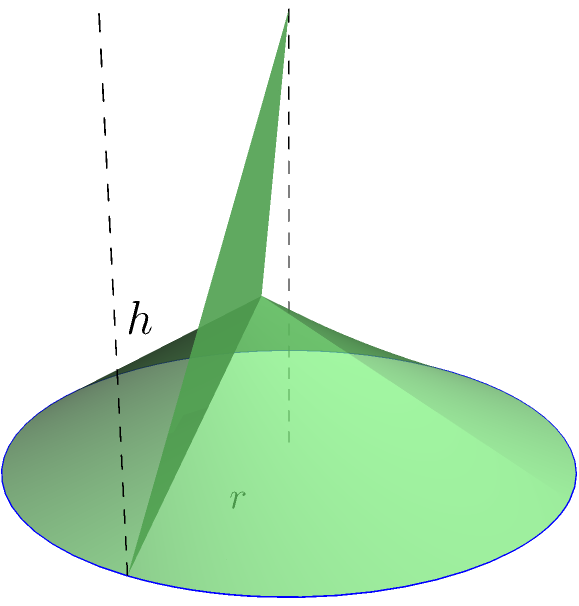During the Kalimudan Festival in Sultan Kudarat, traditional cone-shaped hats are worn. If a hat has a base radius of 20 cm and a height of 30 cm, what is its volume in cubic centimeters? Round your answer to the nearest whole number. To solve this problem, we'll use the formula for the volume of a cone:

$$V = \frac{1}{3}\pi r^2 h$$

Where:
$V$ = volume
$r$ = radius of the base
$h$ = height of the cone

Given:
$r = 20$ cm
$h = 30$ cm

Let's substitute these values into the formula:

$$V = \frac{1}{3}\pi (20\text{ cm})^2 (30\text{ cm})$$

$$V = \frac{1}{3}\pi (400\text{ cm}^2) (30\text{ cm})$$

$$V = \frac{1}{3}\pi (12000\text{ cm}^3)$$

$$V = 4000\pi\text{ cm}^3$$

Now, let's calculate this value:

$$V \approx 12566.37\text{ cm}^3$$

Rounding to the nearest whole number:

$$V \approx 12566\text{ cm}^3$$
Answer: 12566 cm³ 